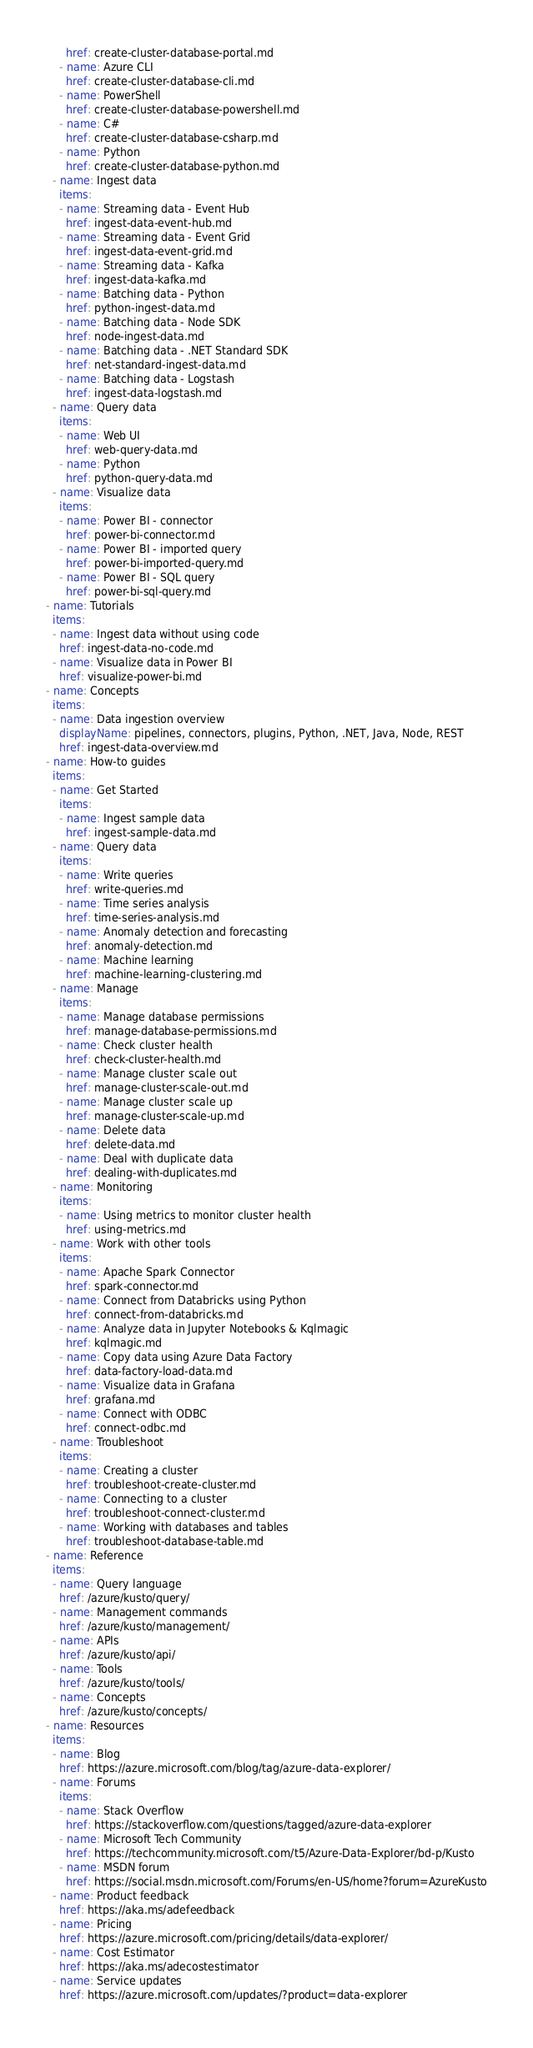Convert code to text. <code><loc_0><loc_0><loc_500><loc_500><_YAML_>      href: create-cluster-database-portal.md
    - name: Azure CLI
      href: create-cluster-database-cli.md
    - name: PowerShell
      href: create-cluster-database-powershell.md
    - name: C#
      href: create-cluster-database-csharp.md
    - name: Python
      href: create-cluster-database-python.md
  - name: Ingest data
    items:
    - name: Streaming data - Event Hub
      href: ingest-data-event-hub.md
    - name: Streaming data - Event Grid
      href: ingest-data-event-grid.md
    - name: Streaming data - Kafka
      href: ingest-data-kafka.md
    - name: Batching data - Python
      href: python-ingest-data.md
    - name: Batching data - Node SDK
      href: node-ingest-data.md
    - name: Batching data - .NET Standard SDK
      href: net-standard-ingest-data.md
    - name: Batching data - Logstash
      href: ingest-data-logstash.md
  - name: Query data
    items:
    - name: Web UI
      href: web-query-data.md
    - name: Python
      href: python-query-data.md
  - name: Visualize data
    items:
    - name: Power BI - connector
      href: power-bi-connector.md
    - name: Power BI - imported query
      href: power-bi-imported-query.md
    - name: Power BI - SQL query
      href: power-bi-sql-query.md
- name: Tutorials
  items:
  - name: Ingest data without using code
    href: ingest-data-no-code.md  
  - name: Visualize data in Power BI
    href: visualize-power-bi.md  
- name: Concepts
  items:
  - name: Data ingestion overview
    displayName: pipelines, connectors, plugins, Python, .NET, Java, Node, REST
    href: ingest-data-overview.md
- name: How-to guides
  items:
  - name: Get Started
    items:
    - name: Ingest sample data
      href: ingest-sample-data.md
  - name: Query data
    items:
    - name: Write queries
      href: write-queries.md
    - name: Time series analysis
      href: time-series-analysis.md
    - name: Anomaly detection and forecasting
      href: anomaly-detection.md
    - name: Machine learning
      href: machine-learning-clustering.md
  - name: Manage
    items:
    - name: Manage database permissions
      href: manage-database-permissions.md
    - name: Check cluster health
      href: check-cluster-health.md
    - name: Manage cluster scale out
      href: manage-cluster-scale-out.md
    - name: Manage cluster scale up
      href: manage-cluster-scale-up.md
    - name: Delete data
      href: delete-data.md
    - name: Deal with duplicate data
      href: dealing-with-duplicates.md
  - name: Monitoring
    items:
    - name: Using metrics to monitor cluster health
      href: using-metrics.md
  - name: Work with other tools
    items:
    - name: Apache Spark Connector
      href: spark-connector.md
    - name: Connect from Databricks using Python
      href: connect-from-databricks.md
    - name: Analyze data in Jupyter Notebooks & Kqlmagic
      href: kqlmagic.md
    - name: Copy data using Azure Data Factory
      href: data-factory-load-data.md 
    - name: Visualize data in Grafana
      href: grafana.md
    - name: Connect with ODBC
      href: connect-odbc.md
  - name: Troubleshoot
    items:
    - name: Creating a cluster
      href: troubleshoot-create-cluster.md
    - name: Connecting to a cluster
      href: troubleshoot-connect-cluster.md
    - name: Working with databases and tables
      href: troubleshoot-database-table.md
- name: Reference
  items:
  - name: Query language
    href: /azure/kusto/query/
  - name: Management commands
    href: /azure/kusto/management/
  - name: APIs
    href: /azure/kusto/api/
  - name: Tools
    href: /azure/kusto/tools/
  - name: Concepts
    href: /azure/kusto/concepts/
- name: Resources
  items:
  - name: Blog
    href: https://azure.microsoft.com/blog/tag/azure-data-explorer/
  - name: Forums
    items:
    - name: Stack Overflow
      href: https://stackoverflow.com/questions/tagged/azure-data-explorer
    - name: Microsoft Tech Community
      href: https://techcommunity.microsoft.com/t5/Azure-Data-Explorer/bd-p/Kusto
    - name: MSDN forum
      href: https://social.msdn.microsoft.com/Forums/en-US/home?forum=AzureKusto
  - name: Product feedback
    href: https://aka.ms/adefeedback
  - name: Pricing
    href: https://azure.microsoft.com/pricing/details/data-explorer/
  - name: Cost Estimator
    href: https://aka.ms/adecostestimator
  - name: Service updates
    href: https://azure.microsoft.com/updates/?product=data-explorer
</code> 